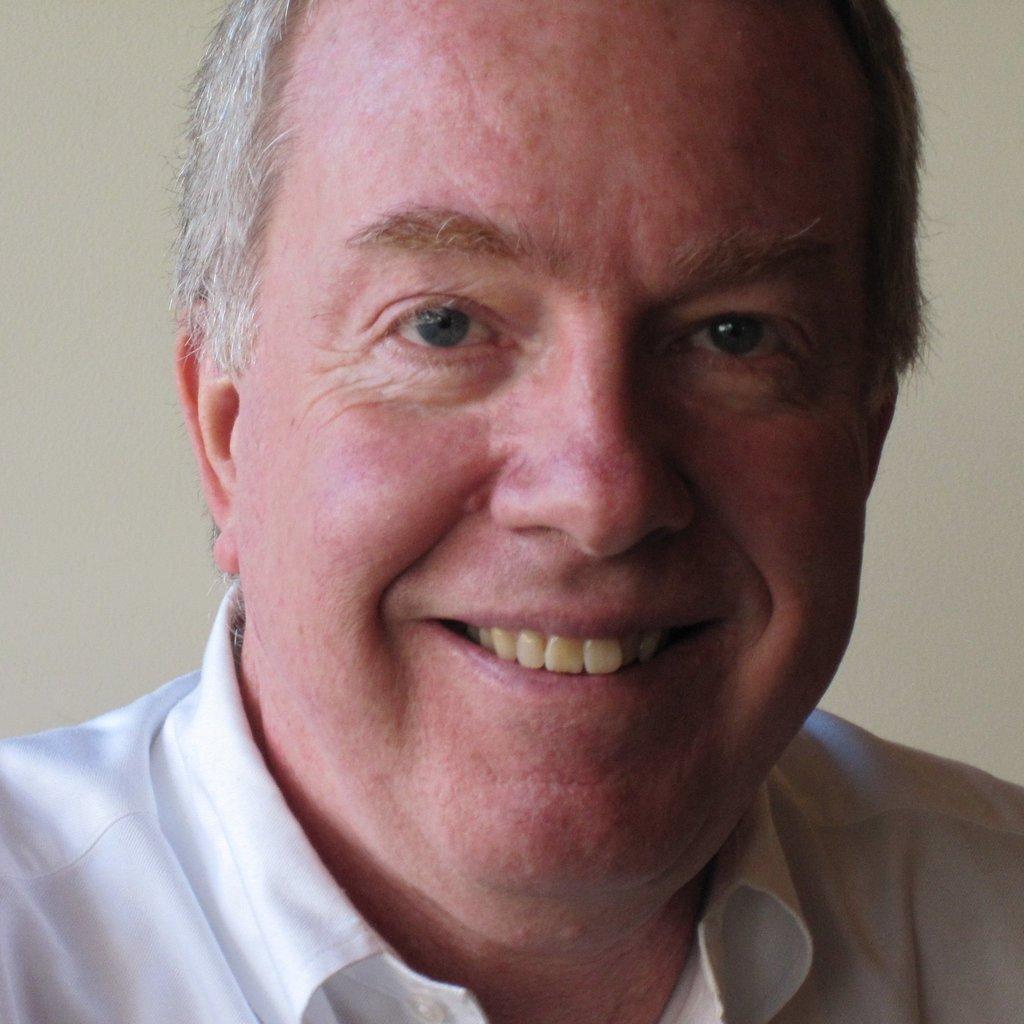Describe this image in one or two sentences. This is the picture of a person with white hair, white shirt and a white background. 